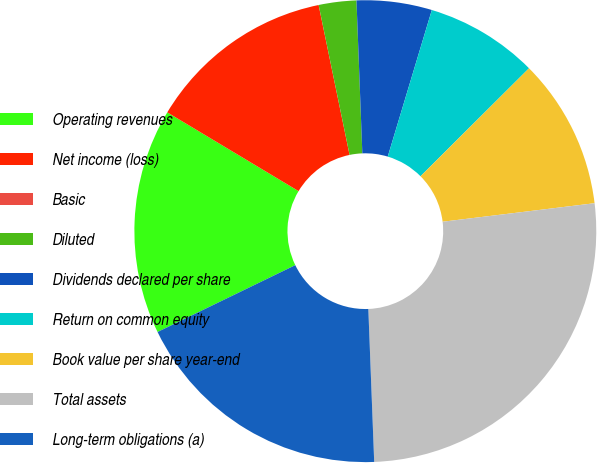Convert chart. <chart><loc_0><loc_0><loc_500><loc_500><pie_chart><fcel>Operating revenues<fcel>Net income (loss)<fcel>Basic<fcel>Diluted<fcel>Dividends declared per share<fcel>Return on common equity<fcel>Book value per share year-end<fcel>Total assets<fcel>Long-term obligations (a)<nl><fcel>15.79%<fcel>13.16%<fcel>0.0%<fcel>2.63%<fcel>5.26%<fcel>7.89%<fcel>10.53%<fcel>26.32%<fcel>18.42%<nl></chart> 